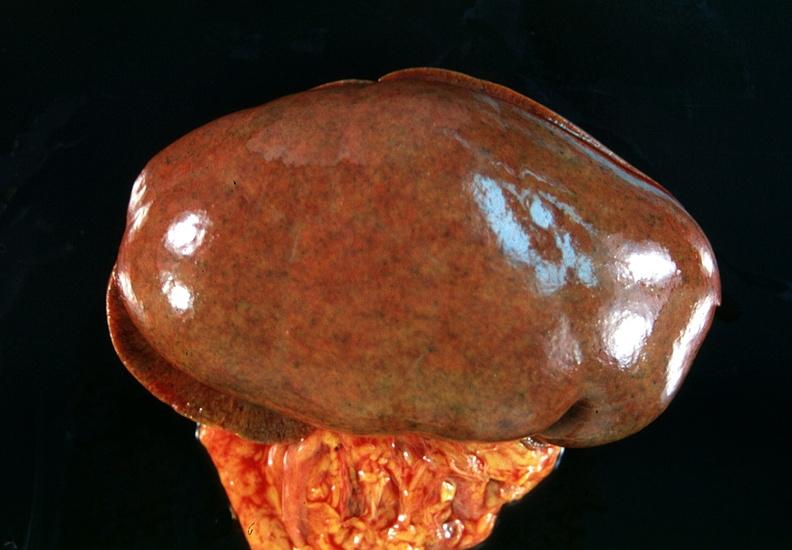does hemorrhage in newborn show kidney, congestion?
Answer the question using a single word or phrase. No 